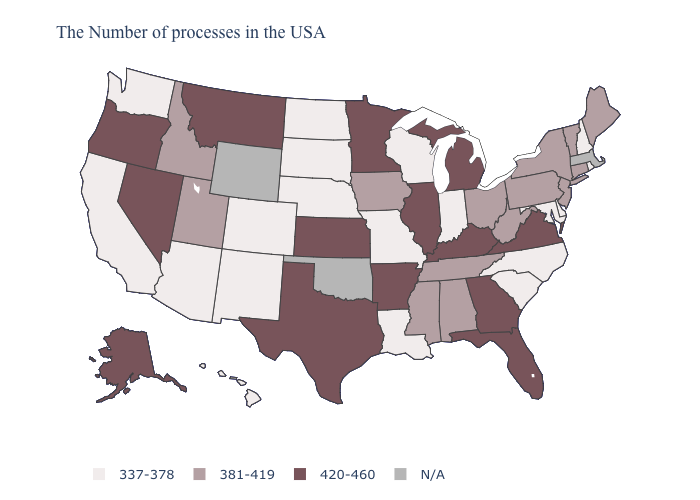Name the states that have a value in the range N/A?
Concise answer only. Massachusetts, Oklahoma, Wyoming. What is the value of Connecticut?
Concise answer only. 381-419. What is the lowest value in states that border Ohio?
Concise answer only. 337-378. What is the value of Michigan?
Write a very short answer. 420-460. Name the states that have a value in the range N/A?
Keep it brief. Massachusetts, Oklahoma, Wyoming. What is the value of Illinois?
Quick response, please. 420-460. Does Kentucky have the highest value in the USA?
Answer briefly. Yes. Which states have the lowest value in the USA?
Give a very brief answer. Rhode Island, New Hampshire, Delaware, Maryland, North Carolina, South Carolina, Indiana, Wisconsin, Louisiana, Missouri, Nebraska, South Dakota, North Dakota, Colorado, New Mexico, Arizona, California, Washington, Hawaii. Does the map have missing data?
Quick response, please. Yes. Name the states that have a value in the range 337-378?
Be succinct. Rhode Island, New Hampshire, Delaware, Maryland, North Carolina, South Carolina, Indiana, Wisconsin, Louisiana, Missouri, Nebraska, South Dakota, North Dakota, Colorado, New Mexico, Arizona, California, Washington, Hawaii. Which states have the lowest value in the Northeast?
Give a very brief answer. Rhode Island, New Hampshire. Does Mississippi have the lowest value in the USA?
Concise answer only. No. Name the states that have a value in the range 337-378?
Quick response, please. Rhode Island, New Hampshire, Delaware, Maryland, North Carolina, South Carolina, Indiana, Wisconsin, Louisiana, Missouri, Nebraska, South Dakota, North Dakota, Colorado, New Mexico, Arizona, California, Washington, Hawaii. Among the states that border Virginia , which have the highest value?
Concise answer only. Kentucky. 